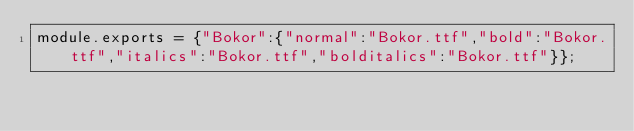<code> <loc_0><loc_0><loc_500><loc_500><_JavaScript_>module.exports = {"Bokor":{"normal":"Bokor.ttf","bold":"Bokor.ttf","italics":"Bokor.ttf","bolditalics":"Bokor.ttf"}};</code> 